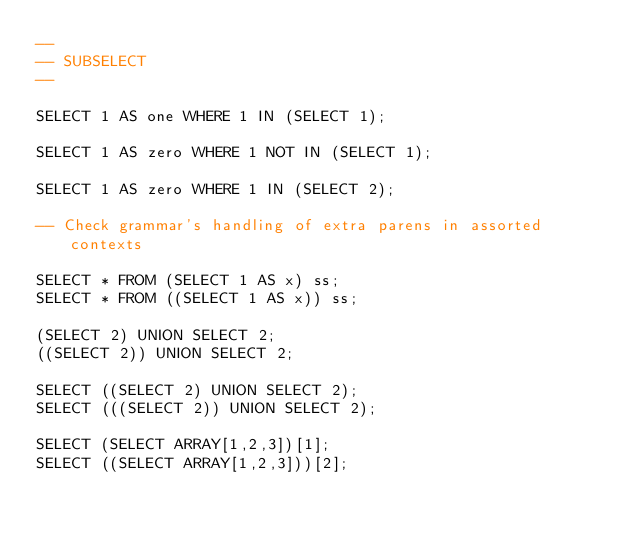<code> <loc_0><loc_0><loc_500><loc_500><_SQL_>--
-- SUBSELECT
--

SELECT 1 AS one WHERE 1 IN (SELECT 1);

SELECT 1 AS zero WHERE 1 NOT IN (SELECT 1);

SELECT 1 AS zero WHERE 1 IN (SELECT 2);

-- Check grammar's handling of extra parens in assorted contexts

SELECT * FROM (SELECT 1 AS x) ss;
SELECT * FROM ((SELECT 1 AS x)) ss;

(SELECT 2) UNION SELECT 2;
((SELECT 2)) UNION SELECT 2;

SELECT ((SELECT 2) UNION SELECT 2);
SELECT (((SELECT 2)) UNION SELECT 2);

SELECT (SELECT ARRAY[1,2,3])[1];
SELECT ((SELECT ARRAY[1,2,3]))[2];</code> 